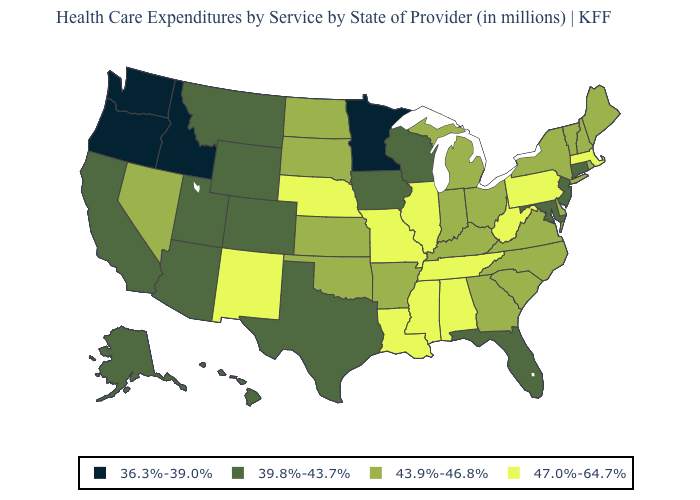What is the value of New Mexico?
Short answer required. 47.0%-64.7%. What is the value of Iowa?
Short answer required. 39.8%-43.7%. What is the value of New Hampshire?
Give a very brief answer. 43.9%-46.8%. What is the highest value in the Northeast ?
Answer briefly. 47.0%-64.7%. Which states have the highest value in the USA?
Answer briefly. Alabama, Illinois, Louisiana, Massachusetts, Mississippi, Missouri, Nebraska, New Mexico, Pennsylvania, Tennessee, West Virginia. Name the states that have a value in the range 36.3%-39.0%?
Answer briefly. Idaho, Minnesota, Oregon, Washington. What is the highest value in the USA?
Short answer required. 47.0%-64.7%. Which states have the highest value in the USA?
Quick response, please. Alabama, Illinois, Louisiana, Massachusetts, Mississippi, Missouri, Nebraska, New Mexico, Pennsylvania, Tennessee, West Virginia. Name the states that have a value in the range 36.3%-39.0%?
Be succinct. Idaho, Minnesota, Oregon, Washington. Name the states that have a value in the range 36.3%-39.0%?
Quick response, please. Idaho, Minnesota, Oregon, Washington. Does Montana have the same value as Ohio?
Keep it brief. No. Does the first symbol in the legend represent the smallest category?
Be succinct. Yes. Among the states that border Idaho , does Montana have the lowest value?
Concise answer only. No. What is the value of Wisconsin?
Quick response, please. 39.8%-43.7%. Does Delaware have the lowest value in the South?
Keep it brief. No. 